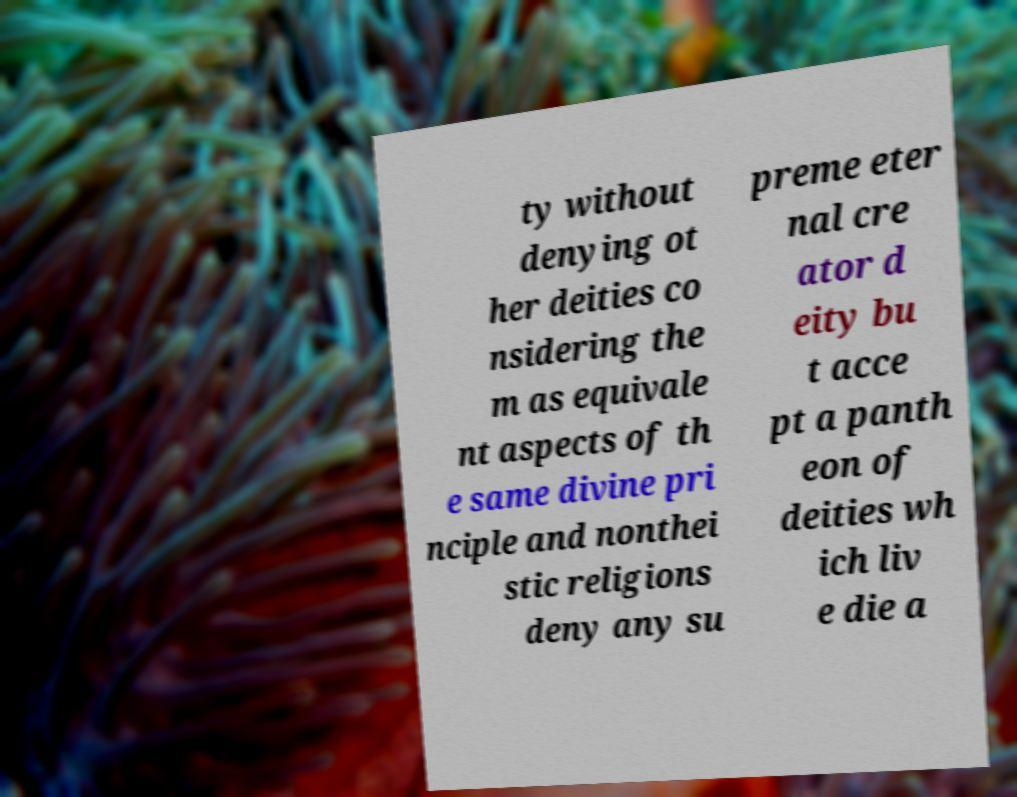There's text embedded in this image that I need extracted. Can you transcribe it verbatim? ty without denying ot her deities co nsidering the m as equivale nt aspects of th e same divine pri nciple and nonthei stic religions deny any su preme eter nal cre ator d eity bu t acce pt a panth eon of deities wh ich liv e die a 